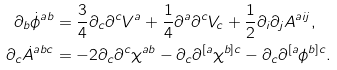<formula> <loc_0><loc_0><loc_500><loc_500>\partial _ { b } { \dot { \phi } } ^ { a b } & = \frac { 3 } { 4 } \partial _ { c } \partial ^ { c } V ^ { a } + \frac { 1 } { 4 } \partial ^ { a } \partial ^ { c } V _ { c } + \frac { 1 } { 2 } \partial _ { i } \partial _ { j } A ^ { a i j } , \\ \partial _ { c } { \dot { A } } ^ { a b c } & = - 2 \partial _ { c } \partial ^ { c } \chi ^ { a b } - \partial _ { c } \partial ^ { [ a } \chi ^ { b ] c } - \partial _ { c } \partial ^ { [ a } \phi ^ { b ] c } .</formula> 